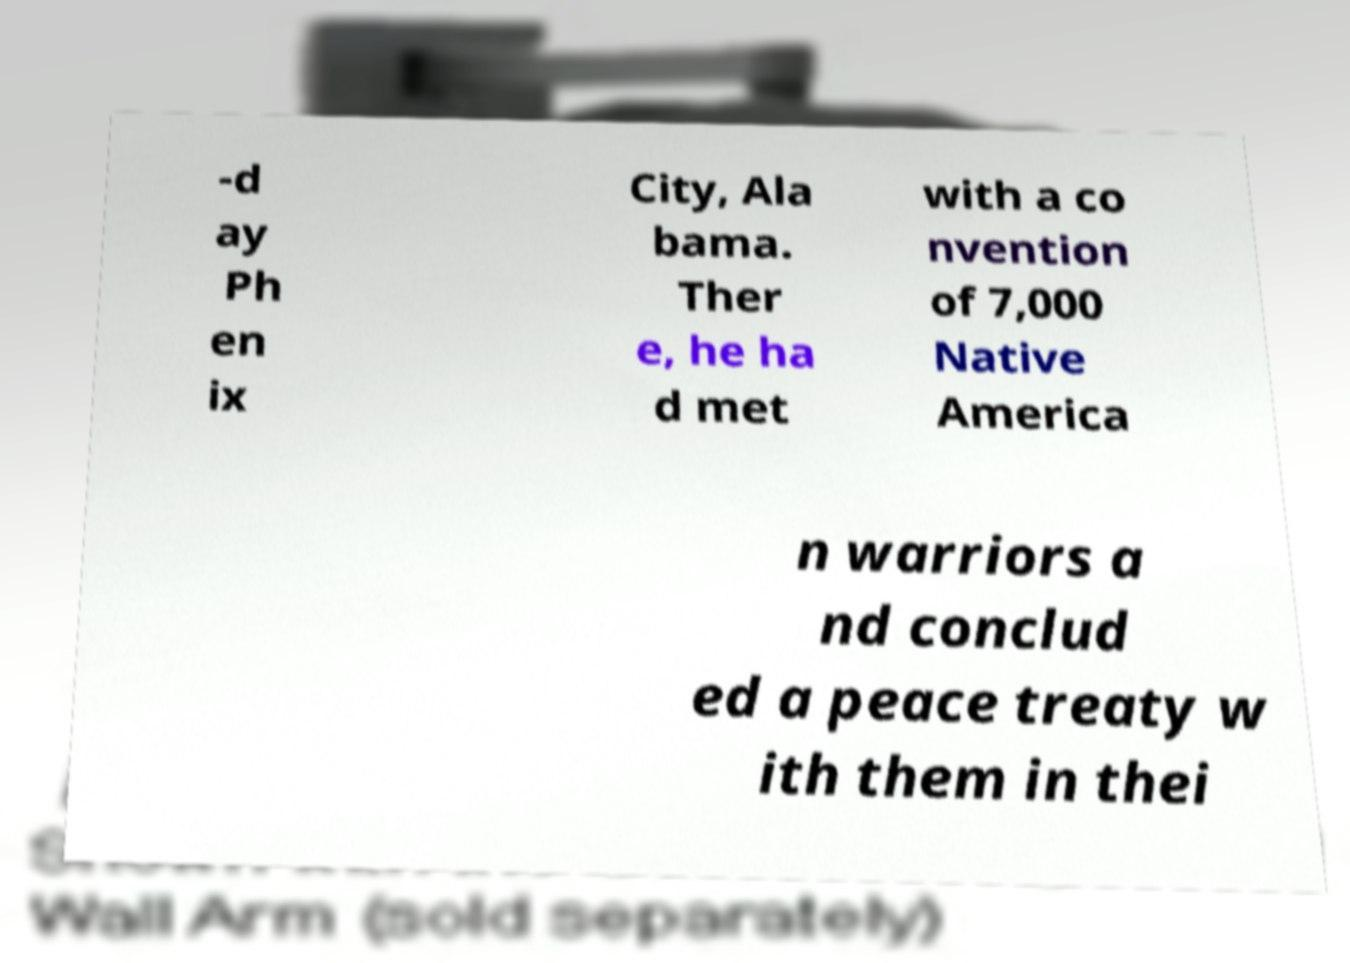There's text embedded in this image that I need extracted. Can you transcribe it verbatim? -d ay Ph en ix City, Ala bama. Ther e, he ha d met with a co nvention of 7,000 Native America n warriors a nd conclud ed a peace treaty w ith them in thei 